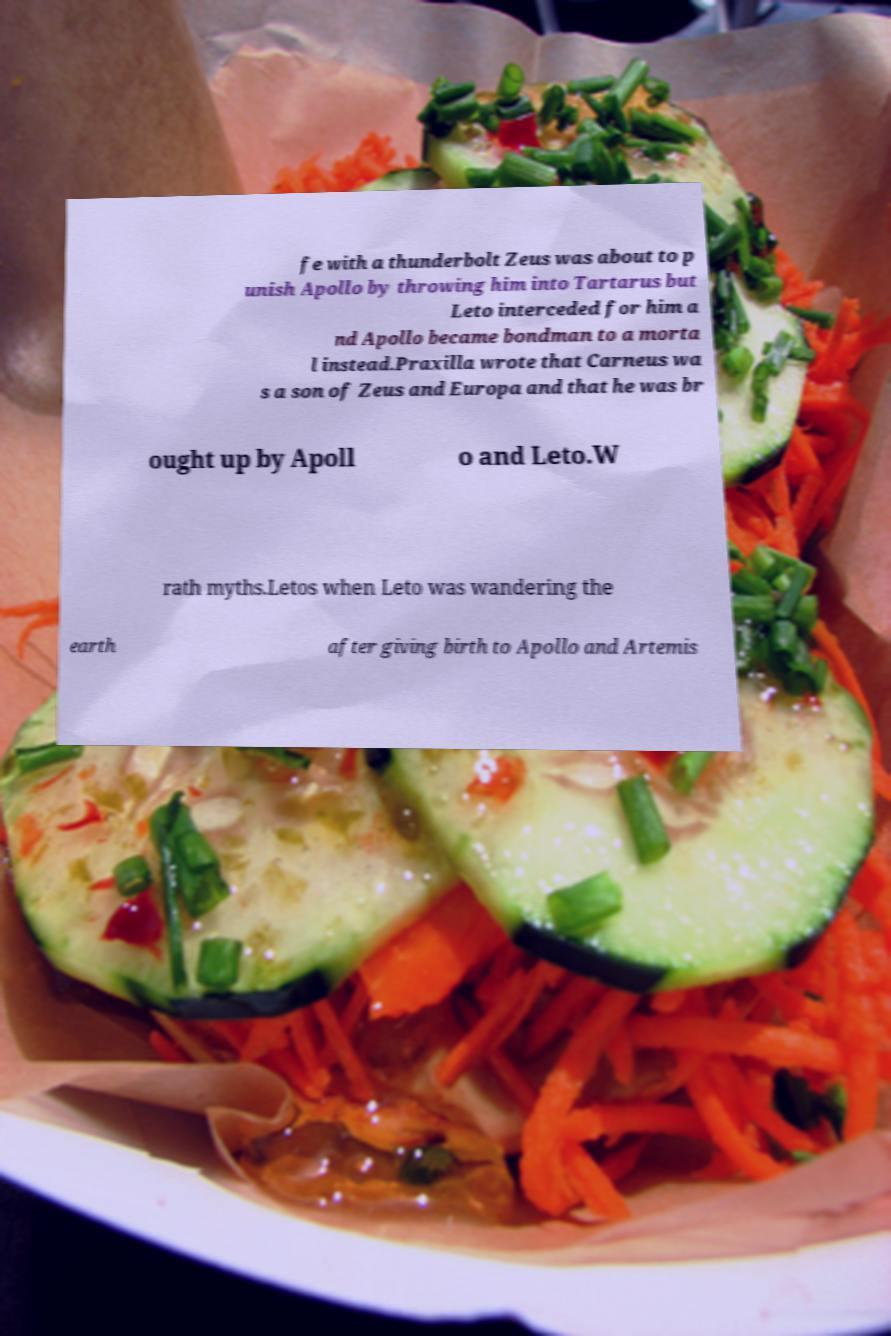Could you assist in decoding the text presented in this image and type it out clearly? fe with a thunderbolt Zeus was about to p unish Apollo by throwing him into Tartarus but Leto interceded for him a nd Apollo became bondman to a morta l instead.Praxilla wrote that Carneus wa s a son of Zeus and Europa and that he was br ought up by Apoll o and Leto.W rath myths.Letos when Leto was wandering the earth after giving birth to Apollo and Artemis 